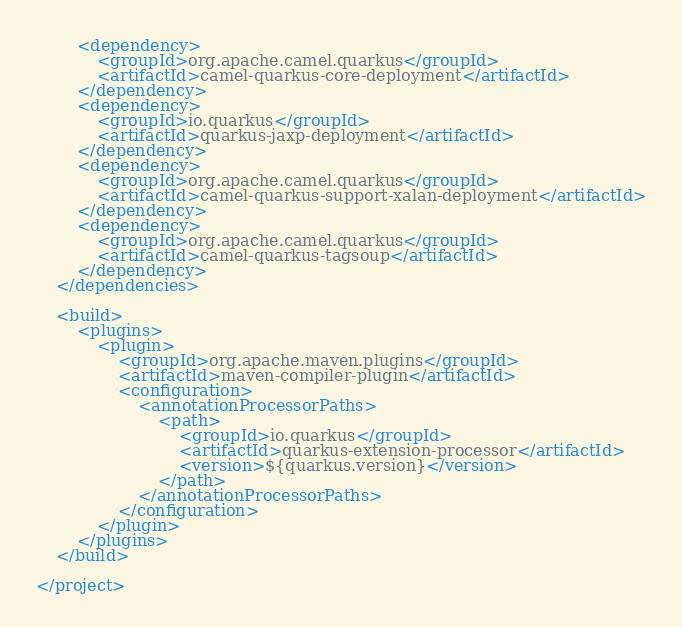<code> <loc_0><loc_0><loc_500><loc_500><_XML_>        <dependency>
            <groupId>org.apache.camel.quarkus</groupId>
            <artifactId>camel-quarkus-core-deployment</artifactId>
        </dependency>
        <dependency>
            <groupId>io.quarkus</groupId>
            <artifactId>quarkus-jaxp-deployment</artifactId>
        </dependency>
        <dependency>
            <groupId>org.apache.camel.quarkus</groupId>
            <artifactId>camel-quarkus-support-xalan-deployment</artifactId>
        </dependency>
        <dependency>
            <groupId>org.apache.camel.quarkus</groupId>
            <artifactId>camel-quarkus-tagsoup</artifactId>
        </dependency>
    </dependencies>

    <build>
        <plugins>
            <plugin>
                <groupId>org.apache.maven.plugins</groupId>
                <artifactId>maven-compiler-plugin</artifactId>
                <configuration>
                    <annotationProcessorPaths>
                        <path>
                            <groupId>io.quarkus</groupId>
                            <artifactId>quarkus-extension-processor</artifactId>
                            <version>${quarkus.version}</version>
                        </path>
                    </annotationProcessorPaths>
                </configuration>
            </plugin>
        </plugins>
    </build>

</project>
</code> 